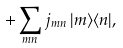<formula> <loc_0><loc_0><loc_500><loc_500>+ \sum _ { m n } j _ { m n } \, | m \rangle \langle n | ,</formula> 